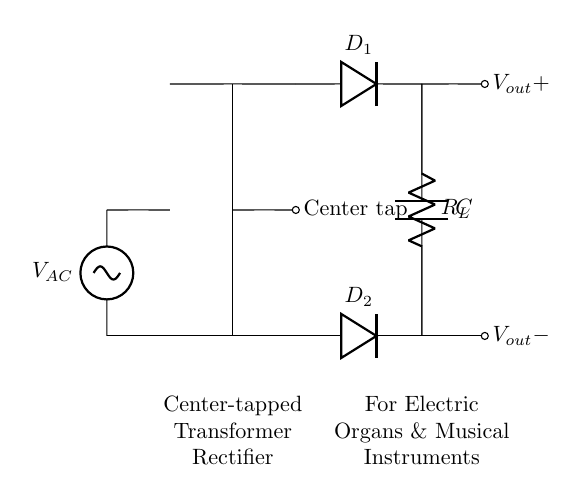What type of transformer is shown? The diagram clearly indicates that it is a center-tapped transformer, as denoted by the label "Center tap" at the middle connection point.
Answer: Center-tapped transformer How many diodes are in this circuit? By examining the circuit, we can see that two diodes, labeled "D1" and "D2," are present, connecting to either side of the transformer.
Answer: Two diodes What is the purpose of the capacitor in this circuit? The capacitor is used for smoothing the output voltage, which helps to reduce fluctuations and provide a more stable direct voltage for the connected load.
Answer: Smoothing output voltage What kind of load does this circuit support? The circuit diagram labels the load as "R_L," which usually represents a resistive load commonly found in electric organs and musical instruments.
Answer: Electric organs and musical instruments What are the output voltage labels in this rectifier circuit? On the right side of the circuit, there are two output voltage labels: "V_out+" and "V_out-," indicating the positive and negative terminals of the output.
Answer: V_out+ and V_out- What is the voltage source type in this circuit? The circuit's voltage source is labeled as a sinusoidal voltage source, indicating that it provides alternating current (AC) to the circuit.
Answer: Sinusoidal voltage source 